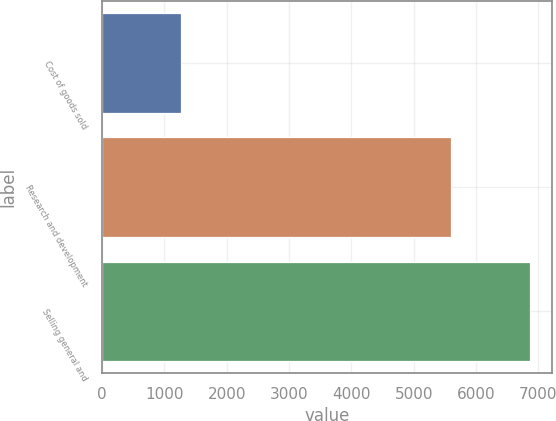Convert chart. <chart><loc_0><loc_0><loc_500><loc_500><bar_chart><fcel>Cost of goods sold<fcel>Research and development<fcel>Selling general and<nl><fcel>1274<fcel>5590<fcel>6873<nl></chart> 